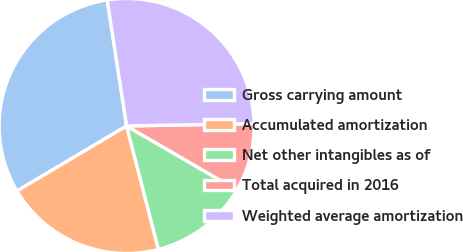Convert chart. <chart><loc_0><loc_0><loc_500><loc_500><pie_chart><fcel>Gross carrying amount<fcel>Accumulated amortization<fcel>Net other intangibles as of<fcel>Total acquired in 2016<fcel>Weighted average amortization<nl><fcel>31.09%<fcel>20.5%<fcel>12.61%<fcel>8.66%<fcel>27.14%<nl></chart> 